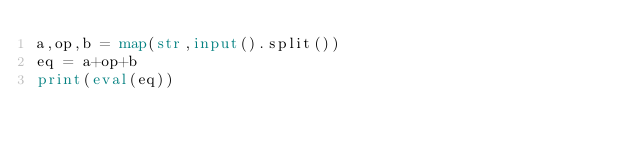Convert code to text. <code><loc_0><loc_0><loc_500><loc_500><_Python_>a,op,b = map(str,input().split())
eq = a+op+b
print(eval(eq))</code> 